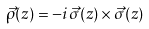<formula> <loc_0><loc_0><loc_500><loc_500>\vec { \rho } ( z ) = - i \vec { \sigma } ( z ) \times \vec { \sigma } ( z )</formula> 